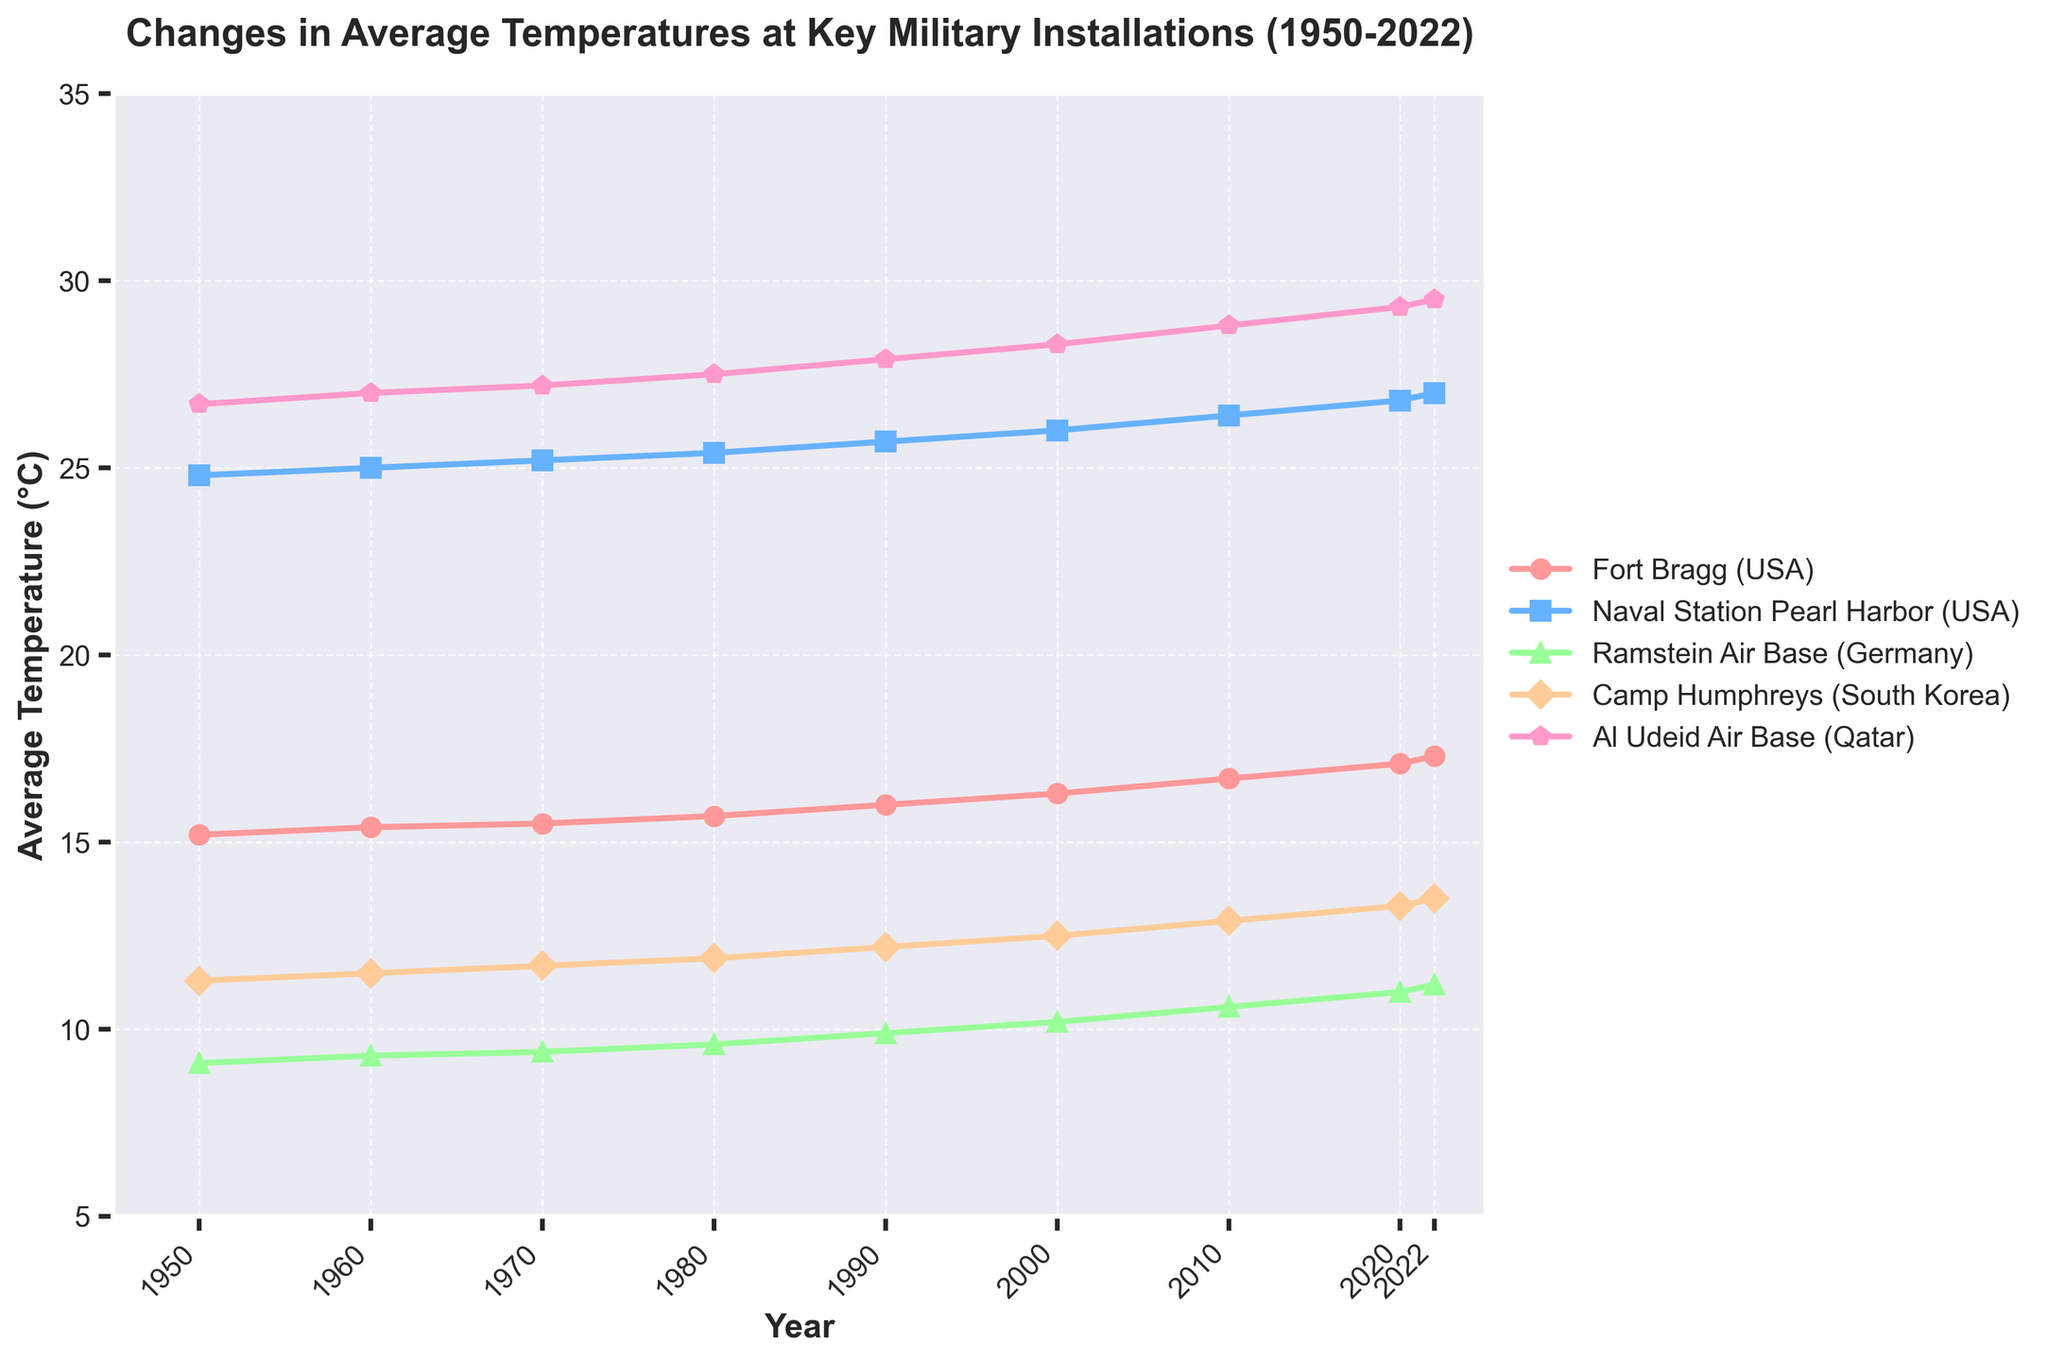How does the average temperature in Fort Bragg in 1950 compare to that in 2022? To find the difference in average temperature at Fort Bragg between 1950 and 2022, look at the values for these years. In 1950, it was 15.2°C, and in 2022, it was 17.3°C. Subtract 15.2 from 17.3 to get the difference.
Answer: 2.1°C Between which years did Naval Station Pearl Harbor experience the most significant rise in temperature? Observe the line representing Naval Station Pearl Harbor and note the increases between consecutive years. The largest rise seems to occur between 2010 (26.4°C) and 2020 (26.8°C). The increase here is 0.4°C.
Answer: 2010-2020 Compare the average temperature at Ramstein Air Base in 1960 and Camp Humphreys in 1980. Which location had a higher temperature? Identify the temperatures for Ramstein Air Base in 1960 (9.3°C) and Camp Humphreys in 1980 (11.9°C). Since 11.9°C is greater than 9.3°C, Camp Humphreys had a higher temperature.
Answer: Camp Humphreys What is the average temperature change per decade at Al Udeid Air Base from 1950 to 2022? To find the average temperature change per decade, note the temperature in 1950 (26.7°C) and in 2022 (29.5°C). The change is 29.5 - 26.7 = 2.8°C over 72 years. Divide this by the number of decades (7.2) to find the average change per decade, which is approximately 0.39°C.
Answer: ~0.39°C Which military installation had the greatest overall increase in average temperature from 1950 to 2022? Calculate the increase for each installation from 1950 to 2022: Fort Bragg (17.3 - 15.2 = 2.1°C), Naval Station Pearl Harbor (27.0 - 24.8 = 2.2°C), Ramstein Air Base (11.2 - 9.1 = 2.1°C), Camp Humphreys (13.5 - 11.3 = 2.2°C), Al Udeid Air Base (29.5 - 26.7 = 2.8°C). The greatest increase is at Al Udeid Air Base with 2.8°C.
Answer: Al Udeid Air Base How does the rate of temperature increase from 2000 to 2022 at Fort Bragg compare to Ramstein Air Base? Calculate the increases: Fort Bragg (2022: 17.3°C, 2000: 16.3°C) results in 1.0°C. Ramstein Air Base (2022: 11.2°C, 2000: 10.2°C) results in 1.0°C. Both installations experienced the same rate of temperature increase of 1.0°C.
Answer: Equal What is the trend of average temperatures at Camp Humphreys from the 1950s to the 2020s? Observe the line for Camp Humphreys from 1950 to 2022, which shows a consistent increase from 11.3°C to 13.5°C. This indicates a trend of rising temperatures over the decades.
Answer: Rising 